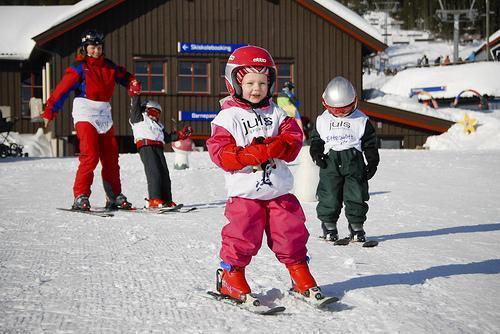How many children have snow shoes on?
Give a very brief answer. 3. 